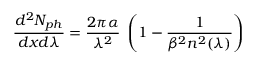<formula> <loc_0><loc_0><loc_500><loc_500>\frac { d ^ { 2 } N _ { p h } } { d x d \lambda } = \frac { 2 \pi \alpha } { \lambda ^ { 2 } } \, \left ( 1 - \frac { 1 } { \beta ^ { 2 } n ^ { 2 } ( \lambda ) } \right )</formula> 